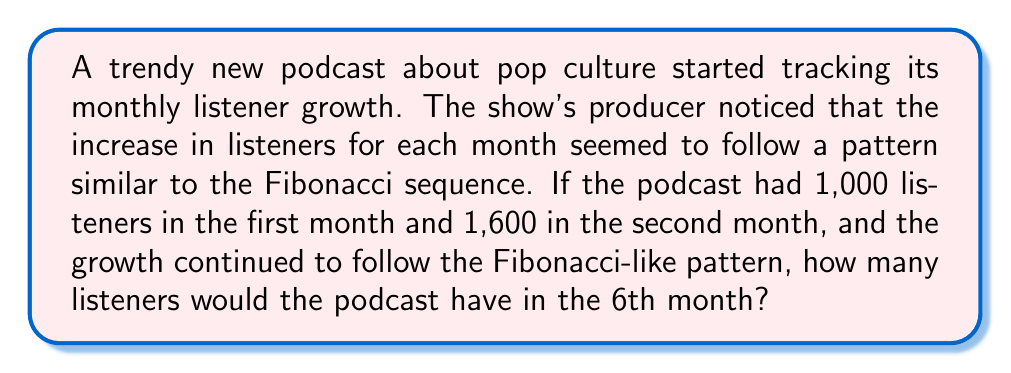Could you help me with this problem? Let's approach this step-by-step:

1) First, recall that in the Fibonacci sequence, each number is the sum of the two preceding ones. The sequence typically starts with 0 and 1, but in this case, we're starting with 1,000 and 1,600.

2) Let's denote the number of listeners in each month as $L_n$, where n is the month number.

   $L_1 = 1,000$
   $L_2 = 1,600$

3) To find $L_3$, we add $L_1$ and $L_2$:
   
   $L_3 = L_1 + L_2 = 1,000 + 1,600 = 2,600$

4) We can continue this pattern:

   $L_4 = L_2 + L_3 = 1,600 + 2,600 = 4,200$
   
   $L_5 = L_3 + L_4 = 2,600 + 4,200 = 6,800$
   
   $L_6 = L_4 + L_5 = 4,200 + 6,800 = 11,000$

5) Therefore, in the 6th month, the podcast would have 11,000 listeners.

This growth pattern mimics the Fibonacci sequence, but with different starting numbers. The ratio between consecutive terms will approach the golden ratio (approximately 1.618) as the sequence progresses, a property shared with the standard Fibonacci sequence.
Answer: 11,000 listeners 